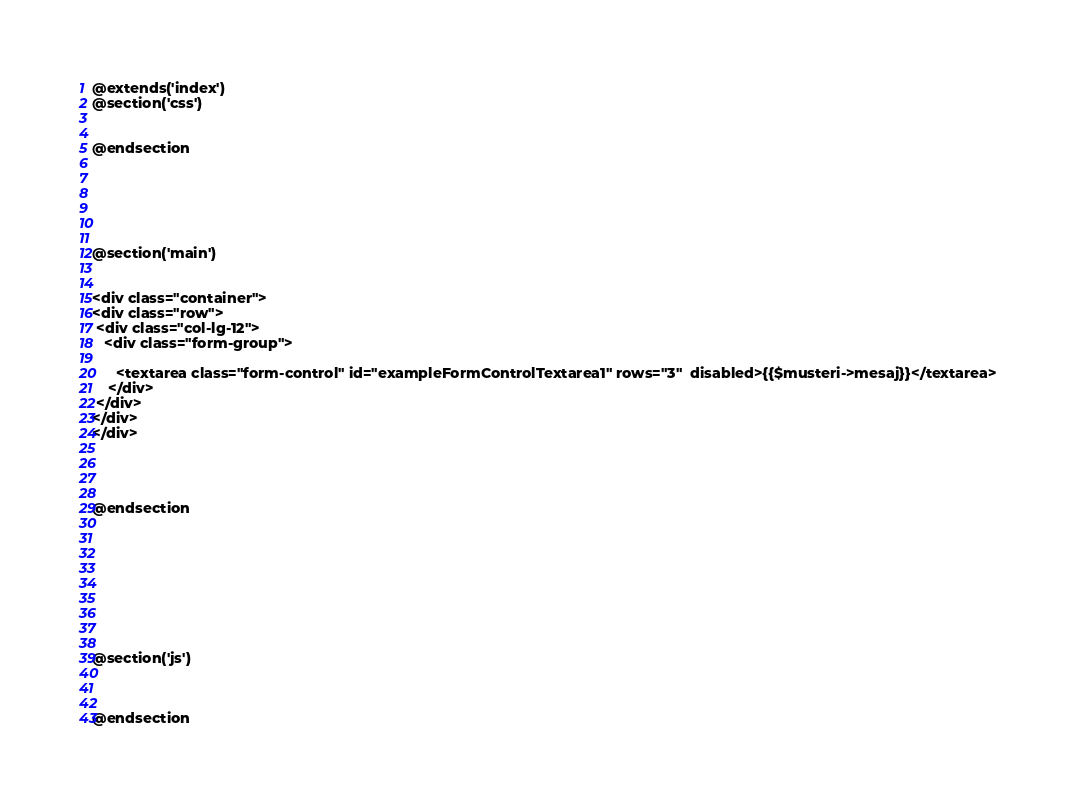Convert code to text. <code><loc_0><loc_0><loc_500><loc_500><_PHP_>@extends('index')
@section('css')


@endsection






@section('main')


<div class="container">
<div class="row">
 <div class="col-lg-12">
   <div class="form-group">

      <textarea class="form-control" id="exampleFormControlTextarea1" rows="3"  disabled>{{$musteri->mesaj}}</textarea>
    </div>
 </div>
</div>
</div>




@endsection









@section('js')



@endsection
</code> 